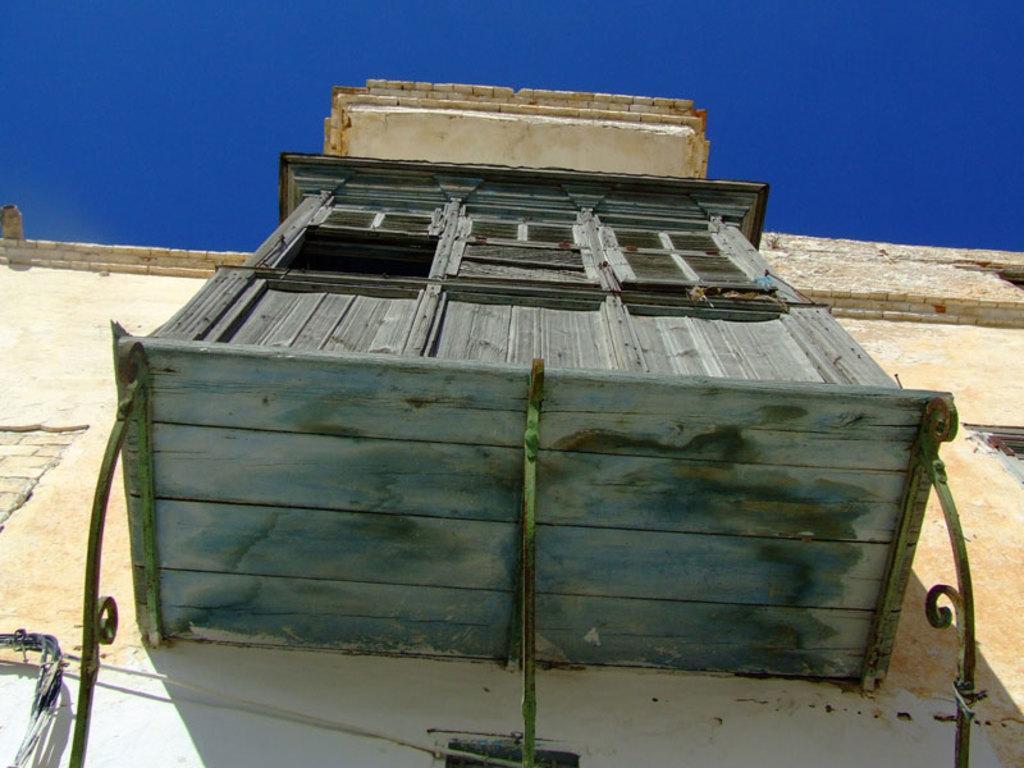Can you describe this image briefly? In this image we can see a building with windows. We can also see the sky. 